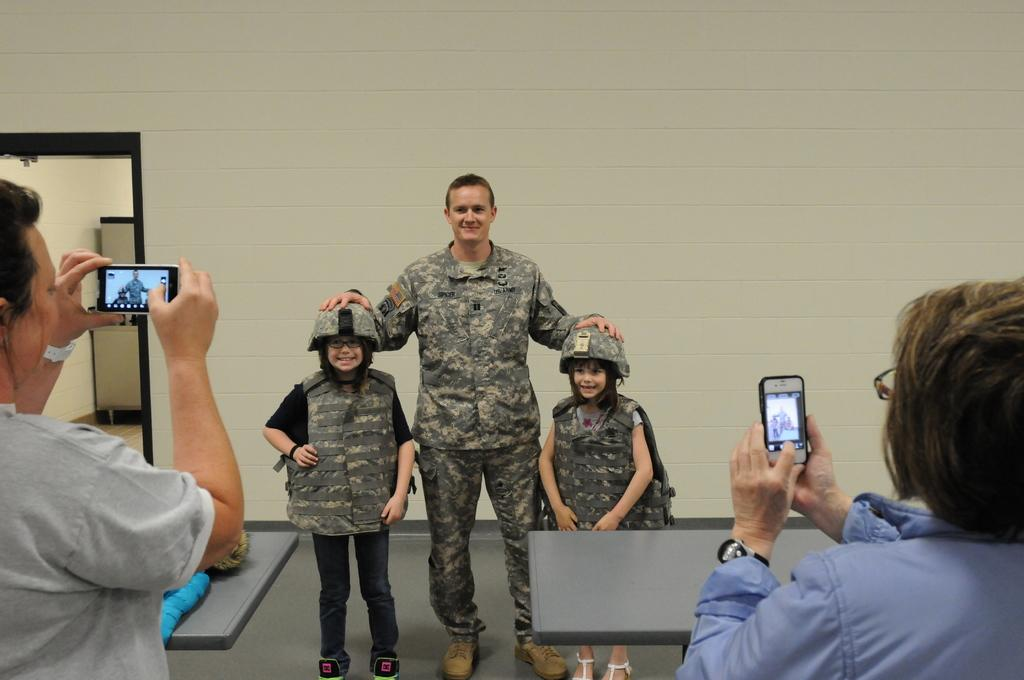What is the main subject of the image? The main subject of the image is a group of people. What are the people in the image doing? The people are standing in the image. Are there any objects being held by the people in the image? Yes, some people in the group are holding mobile phones. How many spiders are crawling on the people in the image? There are no spiders visible in the image; the people are standing without any spiders crawling on them. 